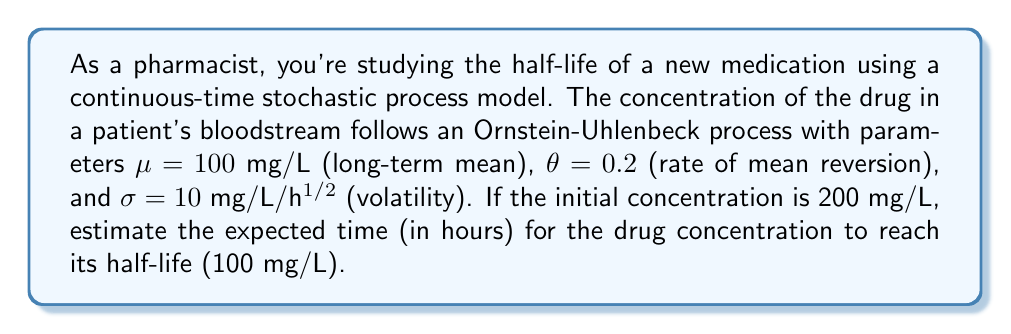Teach me how to tackle this problem. To solve this problem, we'll use the properties of the Ornstein-Uhlenbeck process:

1) The mean of the process at time t is given by:
   $$E[X_t] = X_0e^{-\theta t} + \mu(1 - e^{-\theta t})$$

2) We want to find t when E[X_t] = 100 mg/L (half of the initial concentration):
   $$100 = 200e^{-0.2t} + 100(1 - e^{-0.2t})$$

3) Simplify the equation:
   $$100 = 200e^{-0.2t} + 100 - 100e^{-0.2t}$$
   $$100 = 100e^{-0.2t} + 100$$
   $$0 = 100e^{-0.2t}$$
   $$100e^{-0.2t} = 0$$

4) This equation has no solution, as $e^{-0.2t}$ is always positive. However, we can find when the expected concentration is very close to 100 mg/L.

5) Let's solve for when the difference is less than 1 mg/L:
   $$101 = 200e^{-0.2t} + 100(1 - e^{-0.2t})$$
   $$1 = 100e^{-0.2t}$$
   $$0.01 = e^{-0.2t}$$

6) Take natural log of both sides:
   $$\ln(0.01) = -0.2t$$
   $$t = \frac{-\ln(0.01)}{0.2} \approx 23.03$$

Therefore, it takes approximately 23.03 hours for the expected concentration to be within 1 mg/L of the half-life concentration.
Answer: 23.03 hours 